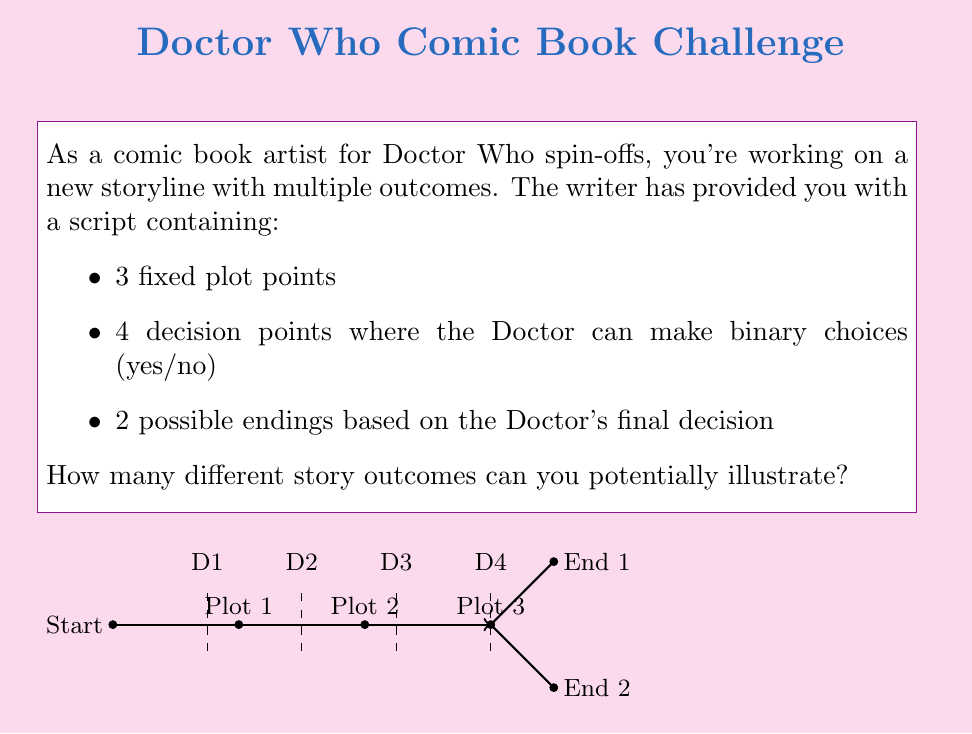Teach me how to tackle this problem. Let's break this down step-by-step:

1) First, we need to understand what contributes to the number of outcomes:
   - The fixed plot points don't create variations, as they're constant across all stories.
   - Each decision point doubles the number of possible paths.
   - The final ending choice also doubles the number of outcomes.

2) For the 4 decision points, we can calculate the number of possible combinations:
   $$2^4 = 16$$
   This is because each decision is binary (yes/no), and we have 4 such decisions.

3) After these decisions, we have 2 possible endings. This further doubles our outcomes:
   $$16 \times 2 = 32$$

4) We can also express this as a single exponential:
   $$2^5 = 32$$
   Where the exponent 5 comes from the 4 decision points plus 1 final ending choice.

5) This result means that for each set of decisions and final ending, there's a unique path through the story, resulting in 32 distinct storylines to illustrate.

This approach uses the multiplication principle of counting, where independent choices are multiplied to get the total number of possibilities.
Answer: $32$ possible story outcomes 